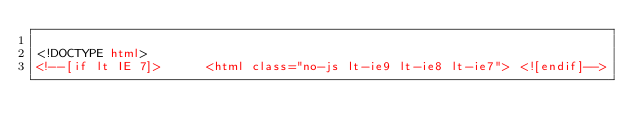<code> <loc_0><loc_0><loc_500><loc_500><_HTML_>
<!DOCTYPE html>
<!--[if lt IE 7]>      <html class="no-js lt-ie9 lt-ie8 lt-ie7"> <![endif]--></code> 